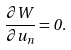<formula> <loc_0><loc_0><loc_500><loc_500>\frac { { \partial } W } { { \partial } u _ { n } } = 0 .</formula> 